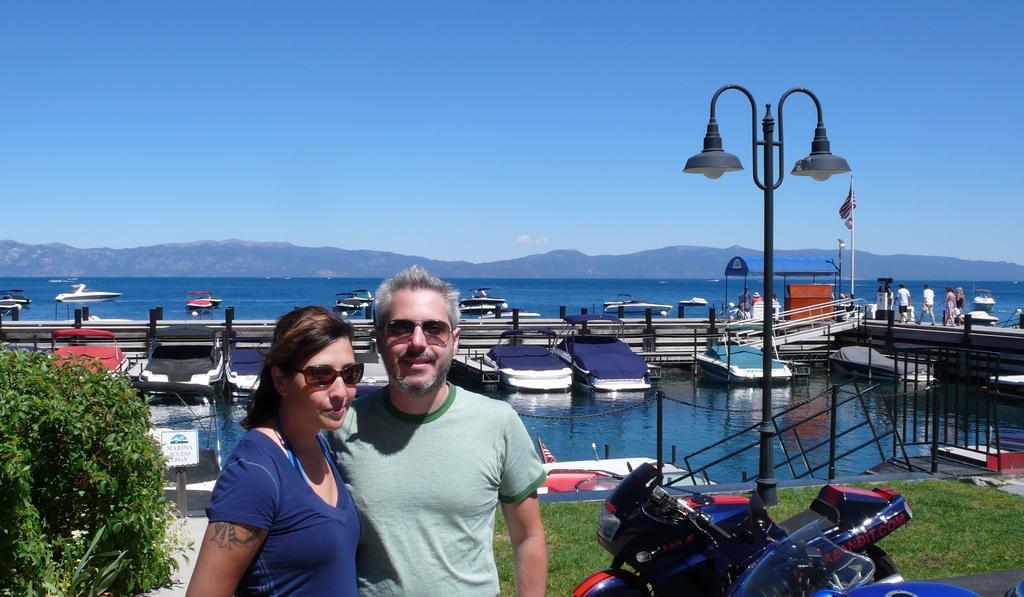Could you give a brief overview of what you see in this image? In this image we can see people, light pole, rods, chains, grille, grass, motorbikes, plant, boats, information board, open-shed, water, flag, hills and blue sky.  